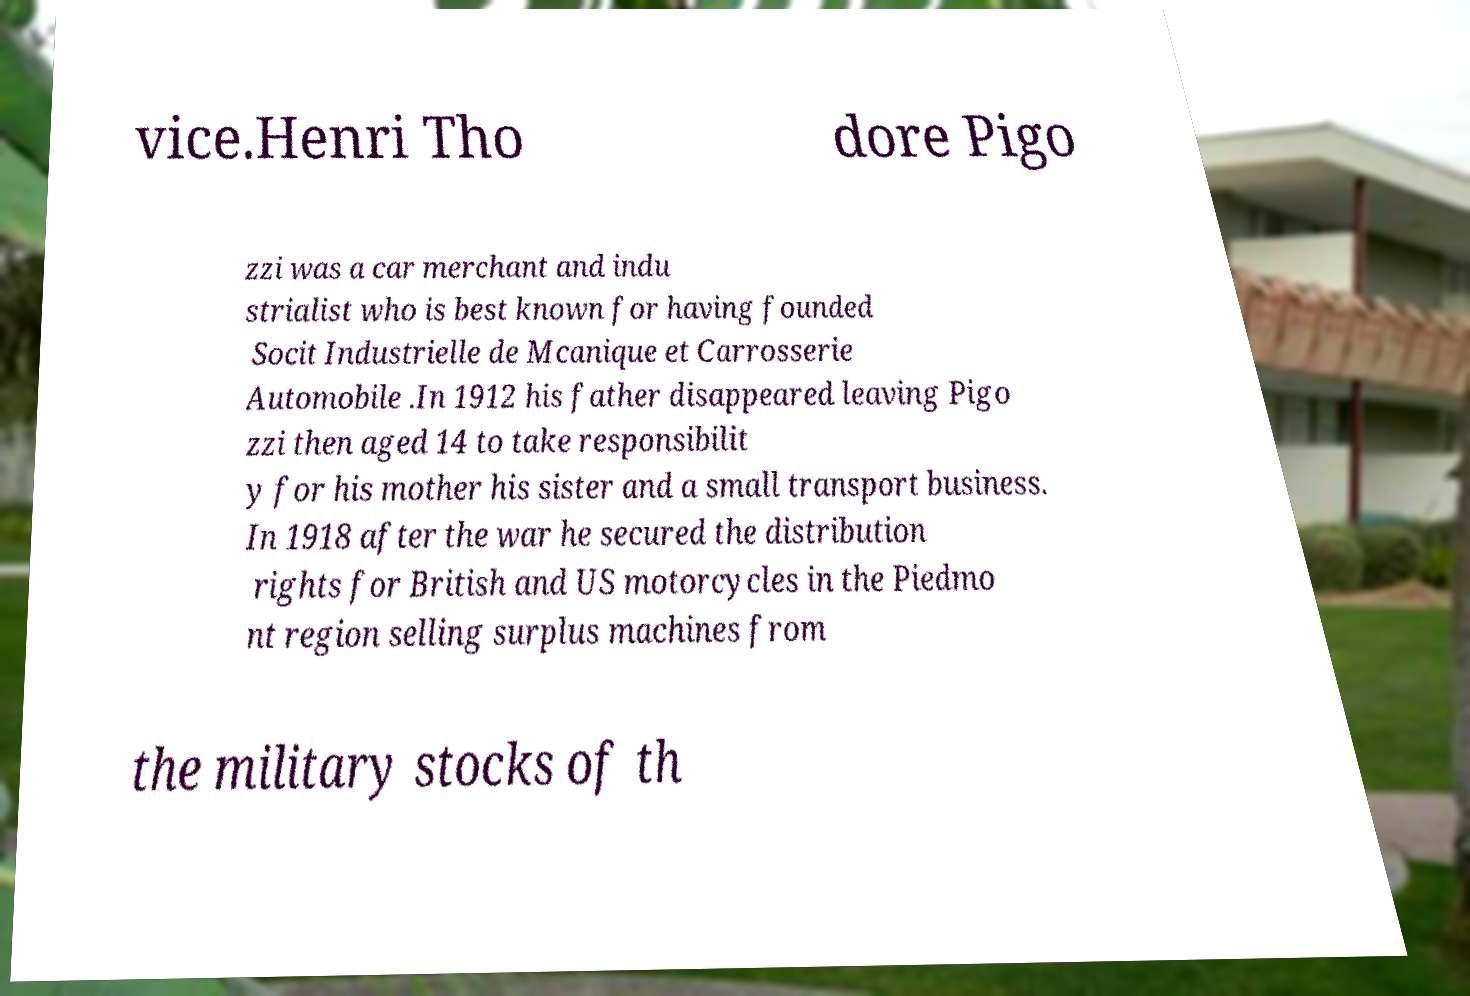There's text embedded in this image that I need extracted. Can you transcribe it verbatim? vice.Henri Tho dore Pigo zzi was a car merchant and indu strialist who is best known for having founded Socit Industrielle de Mcanique et Carrosserie Automobile .In 1912 his father disappeared leaving Pigo zzi then aged 14 to take responsibilit y for his mother his sister and a small transport business. In 1918 after the war he secured the distribution rights for British and US motorcycles in the Piedmo nt region selling surplus machines from the military stocks of th 